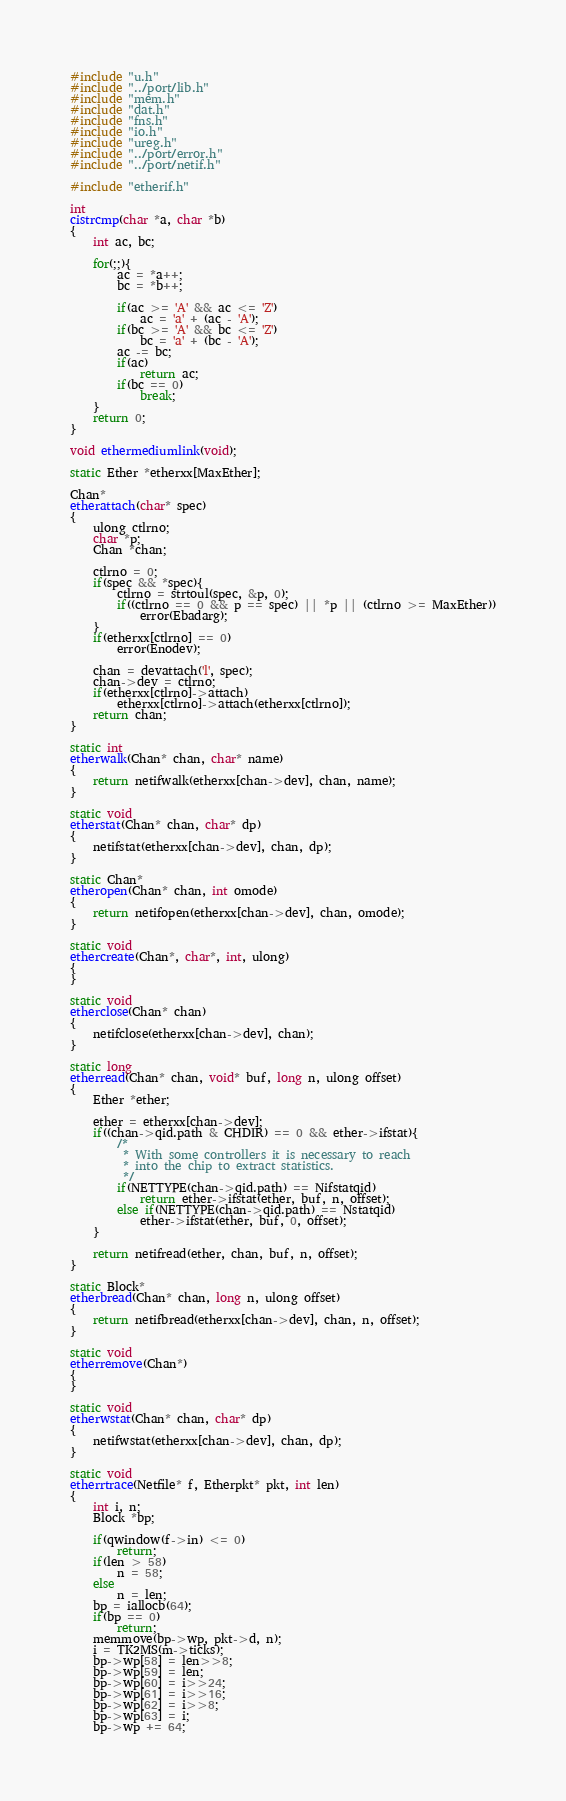<code> <loc_0><loc_0><loc_500><loc_500><_C_>#include "u.h"
#include "../port/lib.h"
#include "mem.h"
#include "dat.h"
#include "fns.h"
#include "io.h"
#include "ureg.h"
#include "../port/error.h"
#include "../port/netif.h"

#include "etherif.h"

int
cistrcmp(char *a, char *b)
{
	int ac, bc;

	for(;;){
		ac = *a++;
		bc = *b++;
	
		if(ac >= 'A' && ac <= 'Z')
			ac = 'a' + (ac - 'A');
		if(bc >= 'A' && bc <= 'Z')
			bc = 'a' + (bc - 'A');
		ac -= bc;
		if(ac)
			return ac;
		if(bc == 0)
			break;
	}
	return 0;
}

void ethermediumlink(void);

static Ether *etherxx[MaxEther];

Chan*
etherattach(char* spec)
{
	ulong ctlrno;
	char *p;
	Chan *chan;

	ctlrno = 0;
	if(spec && *spec){
		ctlrno = strtoul(spec, &p, 0);
		if((ctlrno == 0 && p == spec) || *p || (ctlrno >= MaxEther))
			error(Ebadarg);
	}
	if(etherxx[ctlrno] == 0)
		error(Enodev);

	chan = devattach('l', spec);
	chan->dev = ctlrno;
	if(etherxx[ctlrno]->attach)
		etherxx[ctlrno]->attach(etherxx[ctlrno]);
	return chan;
}

static int
etherwalk(Chan* chan, char* name)
{
	return netifwalk(etherxx[chan->dev], chan, name);
}

static void
etherstat(Chan* chan, char* dp)
{
	netifstat(etherxx[chan->dev], chan, dp);
}

static Chan*
etheropen(Chan* chan, int omode)
{
	return netifopen(etherxx[chan->dev], chan, omode);
}

static void
ethercreate(Chan*, char*, int, ulong)
{
}

static void
etherclose(Chan* chan)
{
	netifclose(etherxx[chan->dev], chan);
}

static long
etherread(Chan* chan, void* buf, long n, ulong offset)
{
	Ether *ether;

	ether = etherxx[chan->dev];
	if((chan->qid.path & CHDIR) == 0 && ether->ifstat){
		/*
		 * With some controllers it is necessary to reach
		 * into the chip to extract statistics.
		 */
		if(NETTYPE(chan->qid.path) == Nifstatqid)
			return ether->ifstat(ether, buf, n, offset);
		else if(NETTYPE(chan->qid.path) == Nstatqid)
			ether->ifstat(ether, buf, 0, offset);
	}

	return netifread(ether, chan, buf, n, offset);
}

static Block*
etherbread(Chan* chan, long n, ulong offset)
{
	return netifbread(etherxx[chan->dev], chan, n, offset);
}

static void
etherremove(Chan*)
{
}

static void
etherwstat(Chan* chan, char* dp)
{
	netifwstat(etherxx[chan->dev], chan, dp);
}

static void
etherrtrace(Netfile* f, Etherpkt* pkt, int len)
{
	int i, n;
	Block *bp;

	if(qwindow(f->in) <= 0)
		return;
	if(len > 58)
		n = 58;
	else
		n = len;
	bp = iallocb(64);
	if(bp == 0)
		return;
	memmove(bp->wp, pkt->d, n);
	i = TK2MS(m->ticks);
	bp->wp[58] = len>>8;
	bp->wp[59] = len;
	bp->wp[60] = i>>24;
	bp->wp[61] = i>>16;
	bp->wp[62] = i>>8;
	bp->wp[63] = i;
	bp->wp += 64;</code> 